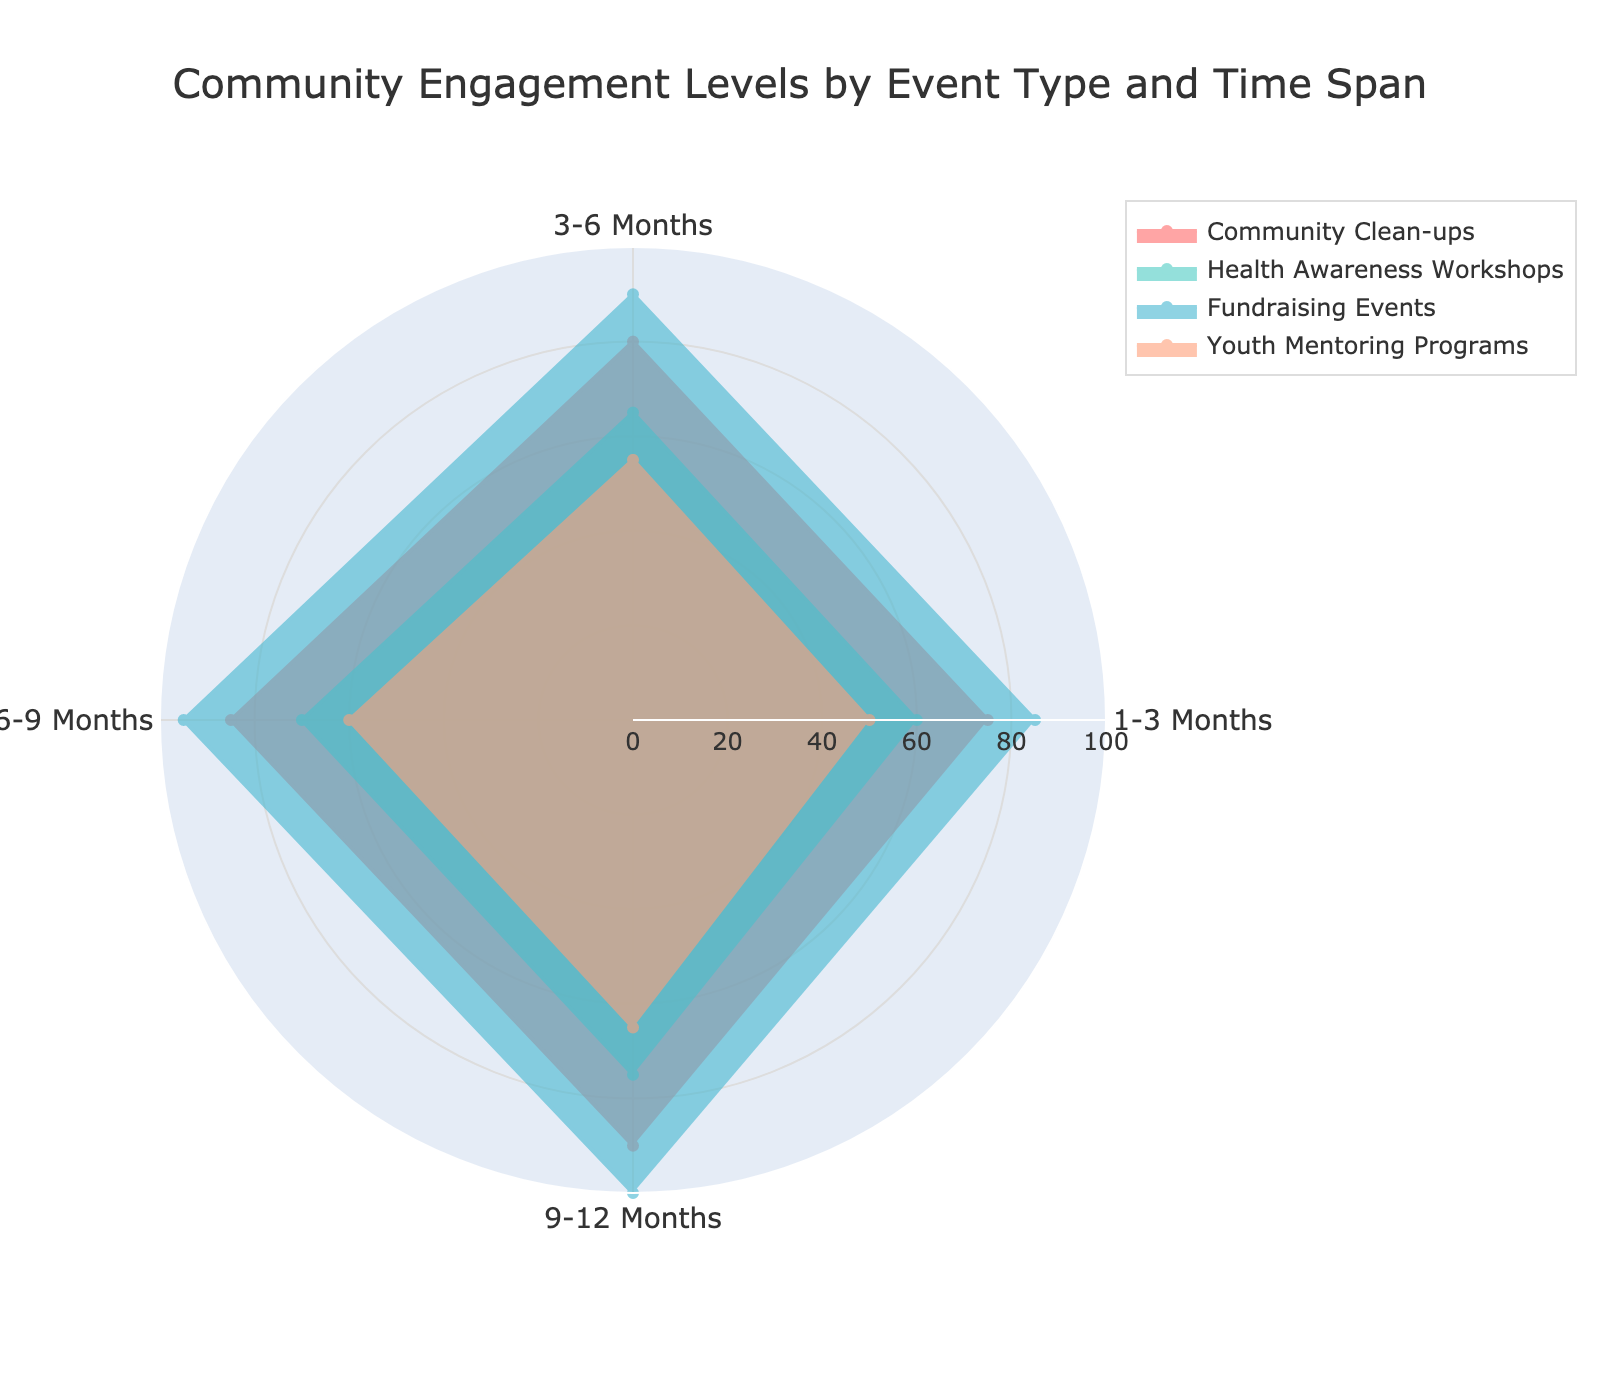What is the title of the radar chart? The title is located at the top of the radar chart, typically in a larger font to capture attention immediately.
Answer: Community Engagement Levels by Event Type and Time Span Which event type has the highest engagement level at the 9-12 month mark? Look at the radial point for the 9-12 months category and compare values across all event types. The highest value corresponds to the Fundraising Events.
Answer: Fundraising Events What is the engagement level for Health Awareness Workshops at the 1-3 month mark? Follow the axis labeled 1-3 Months and locate the value where it intersects with Health Awareness Workshops.
Answer: 60 Which event type shows consistent improvement in engagement over all time spans? Examine each time span for a particular event type and see if the values are increasing. This pattern is consistent for Community Clean-ups, Health Awareness Workshops, Fundraising Events, and Youth Mentoring Programs.
Answer: All event types What is the average engagement level for Fundraising Events across all time spans? Sum up the engagement levels for Fundraising Events (85 + 90 + 95 + 100) and divide by the number of time spans (4). The calculation is (85+90+95+100)/4 = 92.5.
Answer: 92.5 Which event type has the lowest engagement level at the 6-9 month mark? Look at the radial point for the 6-9 months category and compare values across all event types. The lowest value corresponds to Youth Mentoring Programs.
Answer: Youth Mentoring Programs By how many points does Community Clean-ups' engagement increase from 1-3 months to 9-12 months? Subtract the engagement level at 1-3 months from the level at 9-12 months for Community Clean-ups. The calculation is 90 - 75 = 15.
Answer: 15 Across all event types, which time span has the highest engagement level? Compare the engagement levels for each time span across all event types, the highest single value is in Fundraising Events at the 9-12 month mark with 100.
Answer: 9-12 months Between 3-6 months and 6-9 months, which time span shows more improvement for Youth Mentoring Programs? Subtract the engagement level at 3-6 months from the level at 6-9 months for Youth Mentoring Programs. The calculation is (60 - 55) = 5.
Answer: 6-9 months Which color represents the Health Awareness Workshops in the radar chart? Each event type is associated with a different color, and by visual discriminations, the Health Awareness Workshops are represented by the turquoise color.
Answer: Turquoise 